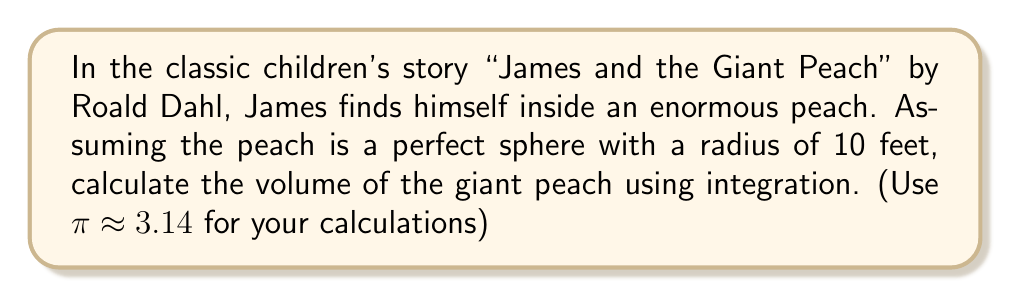Give your solution to this math problem. To calculate the volume of a sphere using integration, we'll use the method of shells:

1) First, we set up the integral. The volume of a sphere is given by:

   $$V = 2\pi \int_0^R y\sqrt{R^2-y^2} dy$$

   where $R$ is the radius of the sphere and $y$ is the distance from the center axis.

2) We know $R = 10$ feet, so our integral becomes:

   $$V = 2\pi \int_0^{10} y\sqrt{100-y^2} dy$$

3) This is a challenging integral to solve directly. Let's use substitution:
   Let $y = 10\sin\theta$, then $dy = 10\cos\theta d\theta$
   When $y = 0$, $\theta = 0$
   When $y = 10$, $\theta = \frac{\pi}{2}$

4) Substituting:

   $$V = 2\pi \int_0^{\frac{\pi}{2}} (10\sin\theta)(10\cos\theta)(10\cos\theta) d\theta$$
   $$= 2000\pi \int_0^{\frac{\pi}{2}} \sin\theta \cos^2\theta d\theta$$

5) This integral can be solved using the identity $\cos^2\theta = \frac{1+\cos2\theta}{2}$:

   $$V = 1000\pi \int_0^{\frac{\pi}{2}} \sin\theta (1+\cos2\theta) d\theta$$
   $$= 1000\pi [-\cos\theta - \frac{1}{4}\cos2\theta]_0^{\frac{\pi}{2}}$$
   $$= 1000\pi [(0 - 0) - (-1 - \frac{1}{4})]$$
   $$= 1000\pi (\frac{5}{4})$$
   $$= 1250\pi$$

6) Using $\pi \approx 3.14$:

   $$V \approx 1250 * 3.14 = 3925$$ cubic feet
Answer: $3925$ cubic feet 